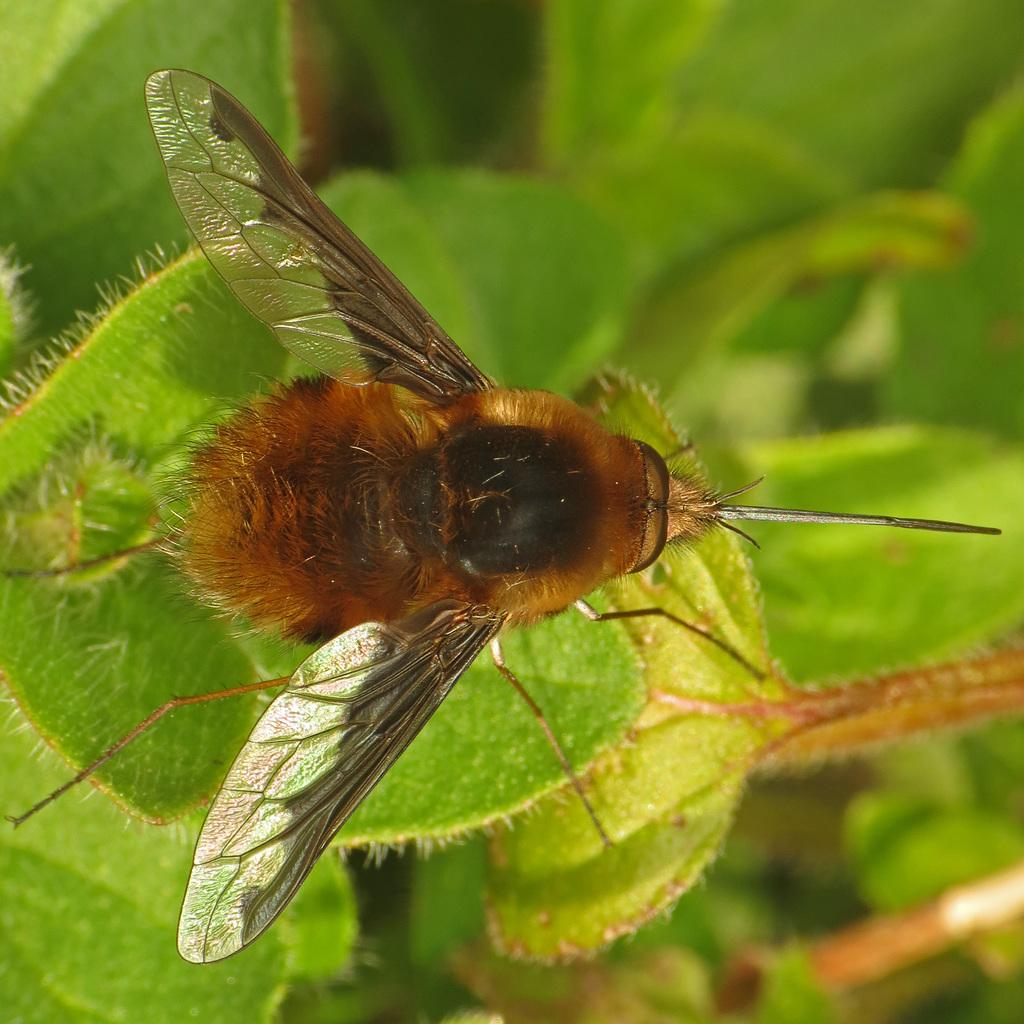What type of insect is present in the image? There is a house fly in the image. Where is the house fly located in the image? The house fly is sitting on green leaves. Can you see the house fly running up a mountain in the image? No, there is no mountain present in the image, and the house fly is sitting on green leaves, not running. 